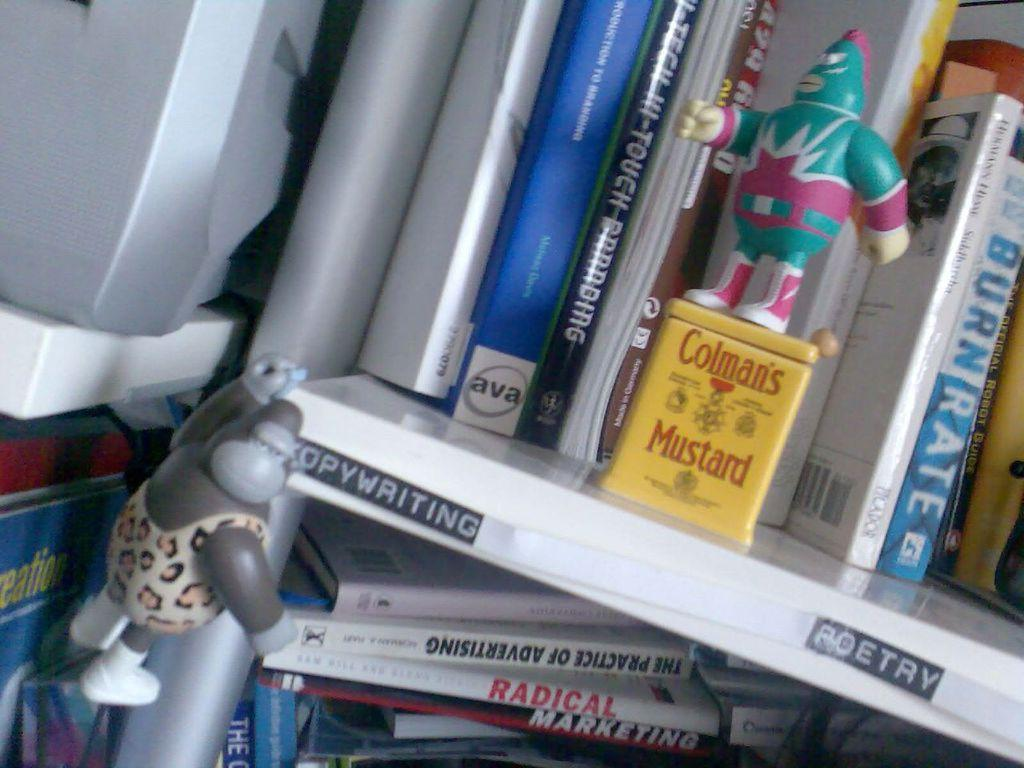<image>
Offer a succinct explanation of the picture presented. the word poetry that is below a book 